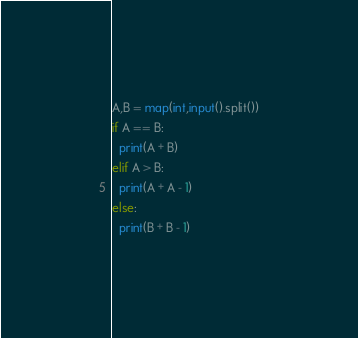<code> <loc_0><loc_0><loc_500><loc_500><_Python_>A,B = map(int,input().split())
if A == B:
  print(A + B)
elif A > B:
  print(A + A - 1)
else:
  print(B + B - 1)</code> 